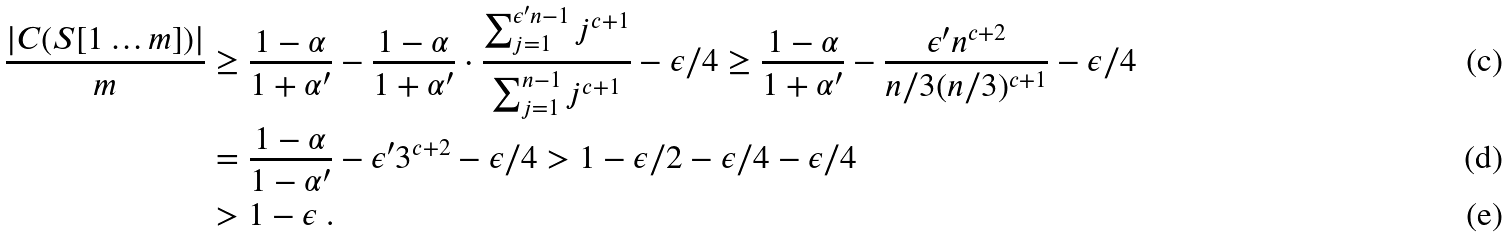Convert formula to latex. <formula><loc_0><loc_0><loc_500><loc_500>\frac { | C ( S [ 1 \dots m ] ) | } { m } & \geq \frac { 1 - \alpha } { 1 + \alpha ^ { \prime } } - \frac { 1 - \alpha } { 1 + \alpha ^ { \prime } } \cdot \frac { \sum _ { j = 1 } ^ { \epsilon ^ { \prime } n - 1 } j ^ { c + 1 } } { \sum _ { j = 1 } ^ { n - 1 } j ^ { c + 1 } } - \epsilon / 4 \geq \frac { 1 - \alpha } { 1 + \alpha ^ { \prime } } - \frac { \epsilon ^ { \prime } n ^ { c + 2 } } { n / 3 ( n / 3 ) ^ { c + 1 } } - \epsilon / 4 \\ & = \frac { 1 - \alpha } { 1 - \alpha ^ { \prime } } - \epsilon ^ { \prime } 3 ^ { c + 2 } - \epsilon / 4 > 1 - \epsilon / 2 - \epsilon / 4 - \epsilon / 4 \\ & > 1 - \epsilon \ .</formula> 